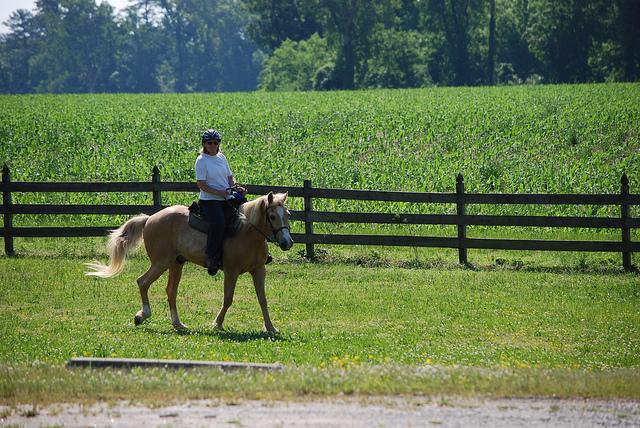What color is the horse?
Give a very brief answer. Tan. What is doing with the stick?
Keep it brief. Riding. Is it winter?
Short answer required. No. What is the color of the horse?
Quick response, please. Tan. Does he own the horse?
Write a very short answer. Yes. 